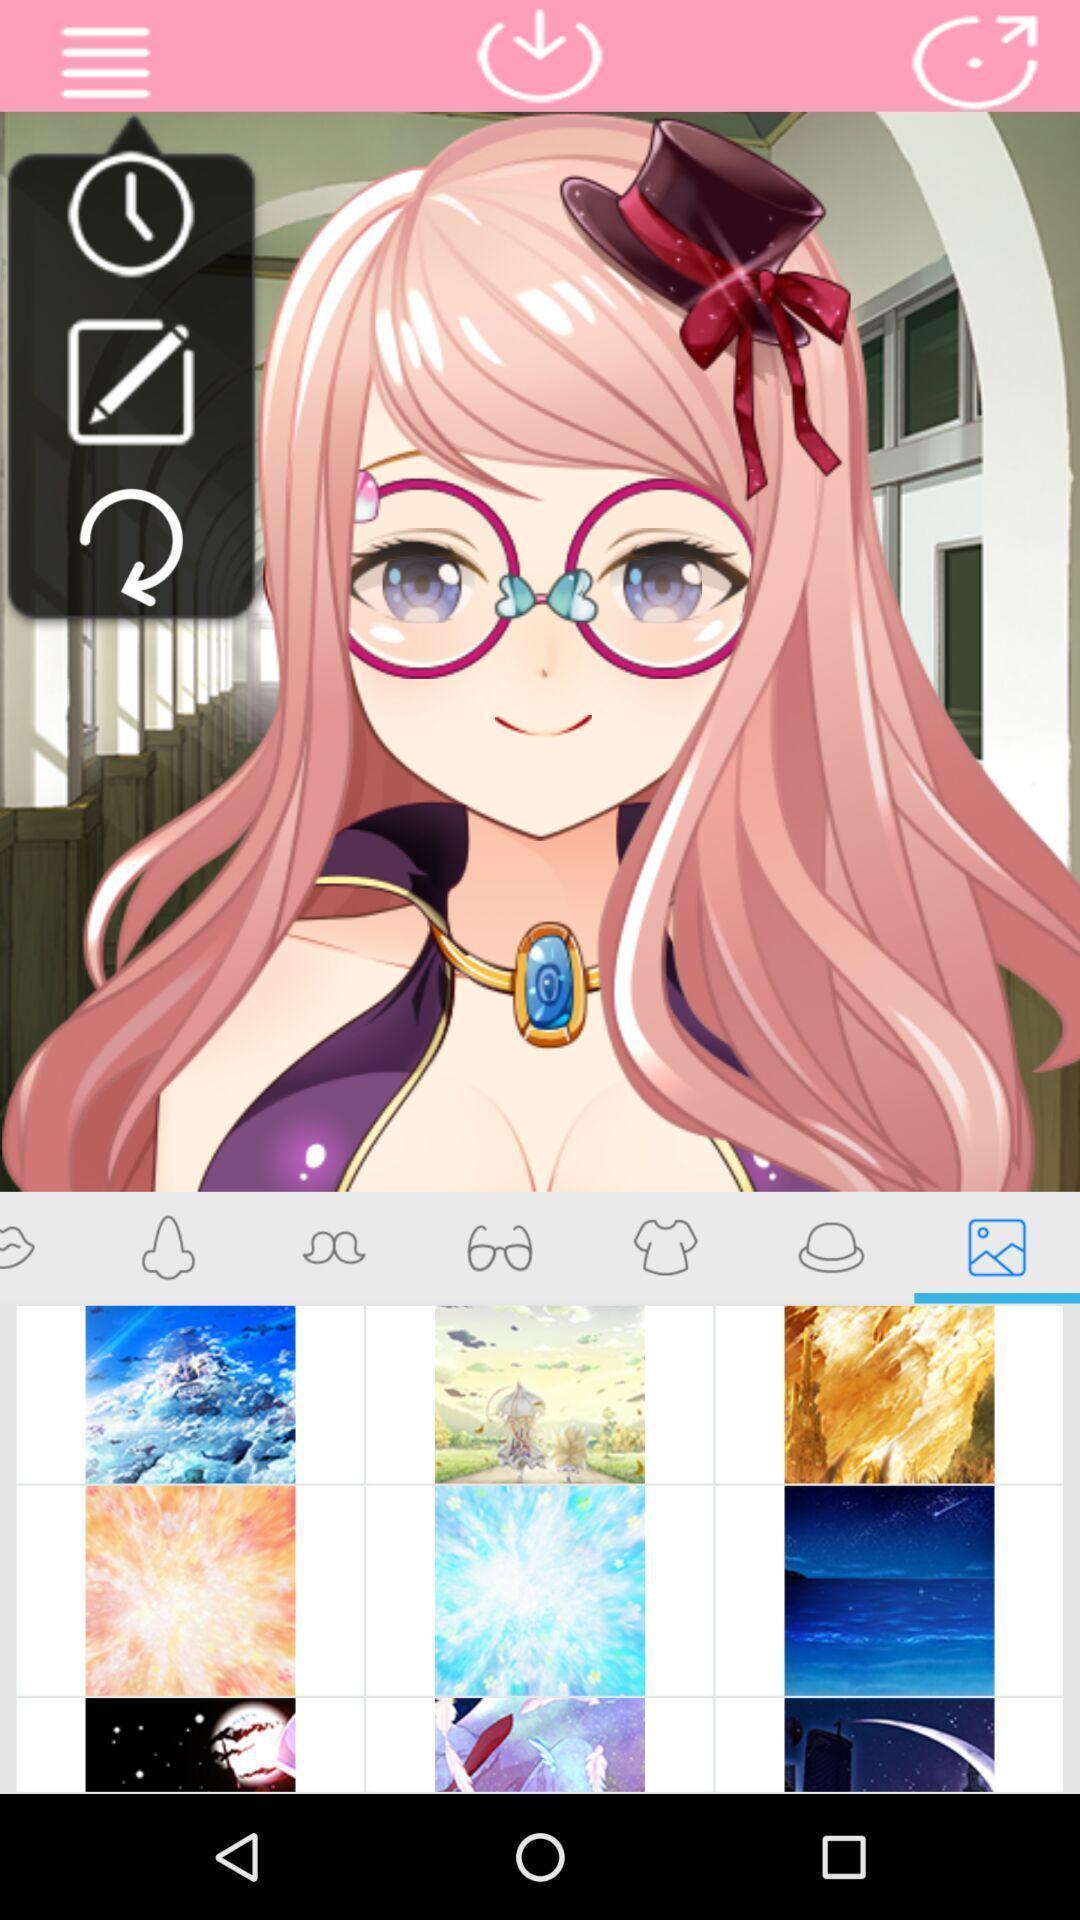What details can you identify in this image? Screen shows different edit options for an image. 